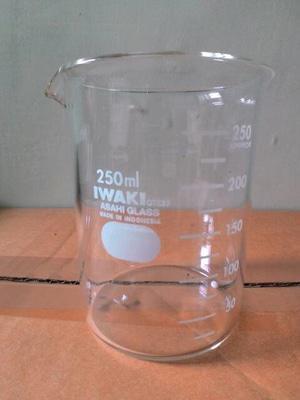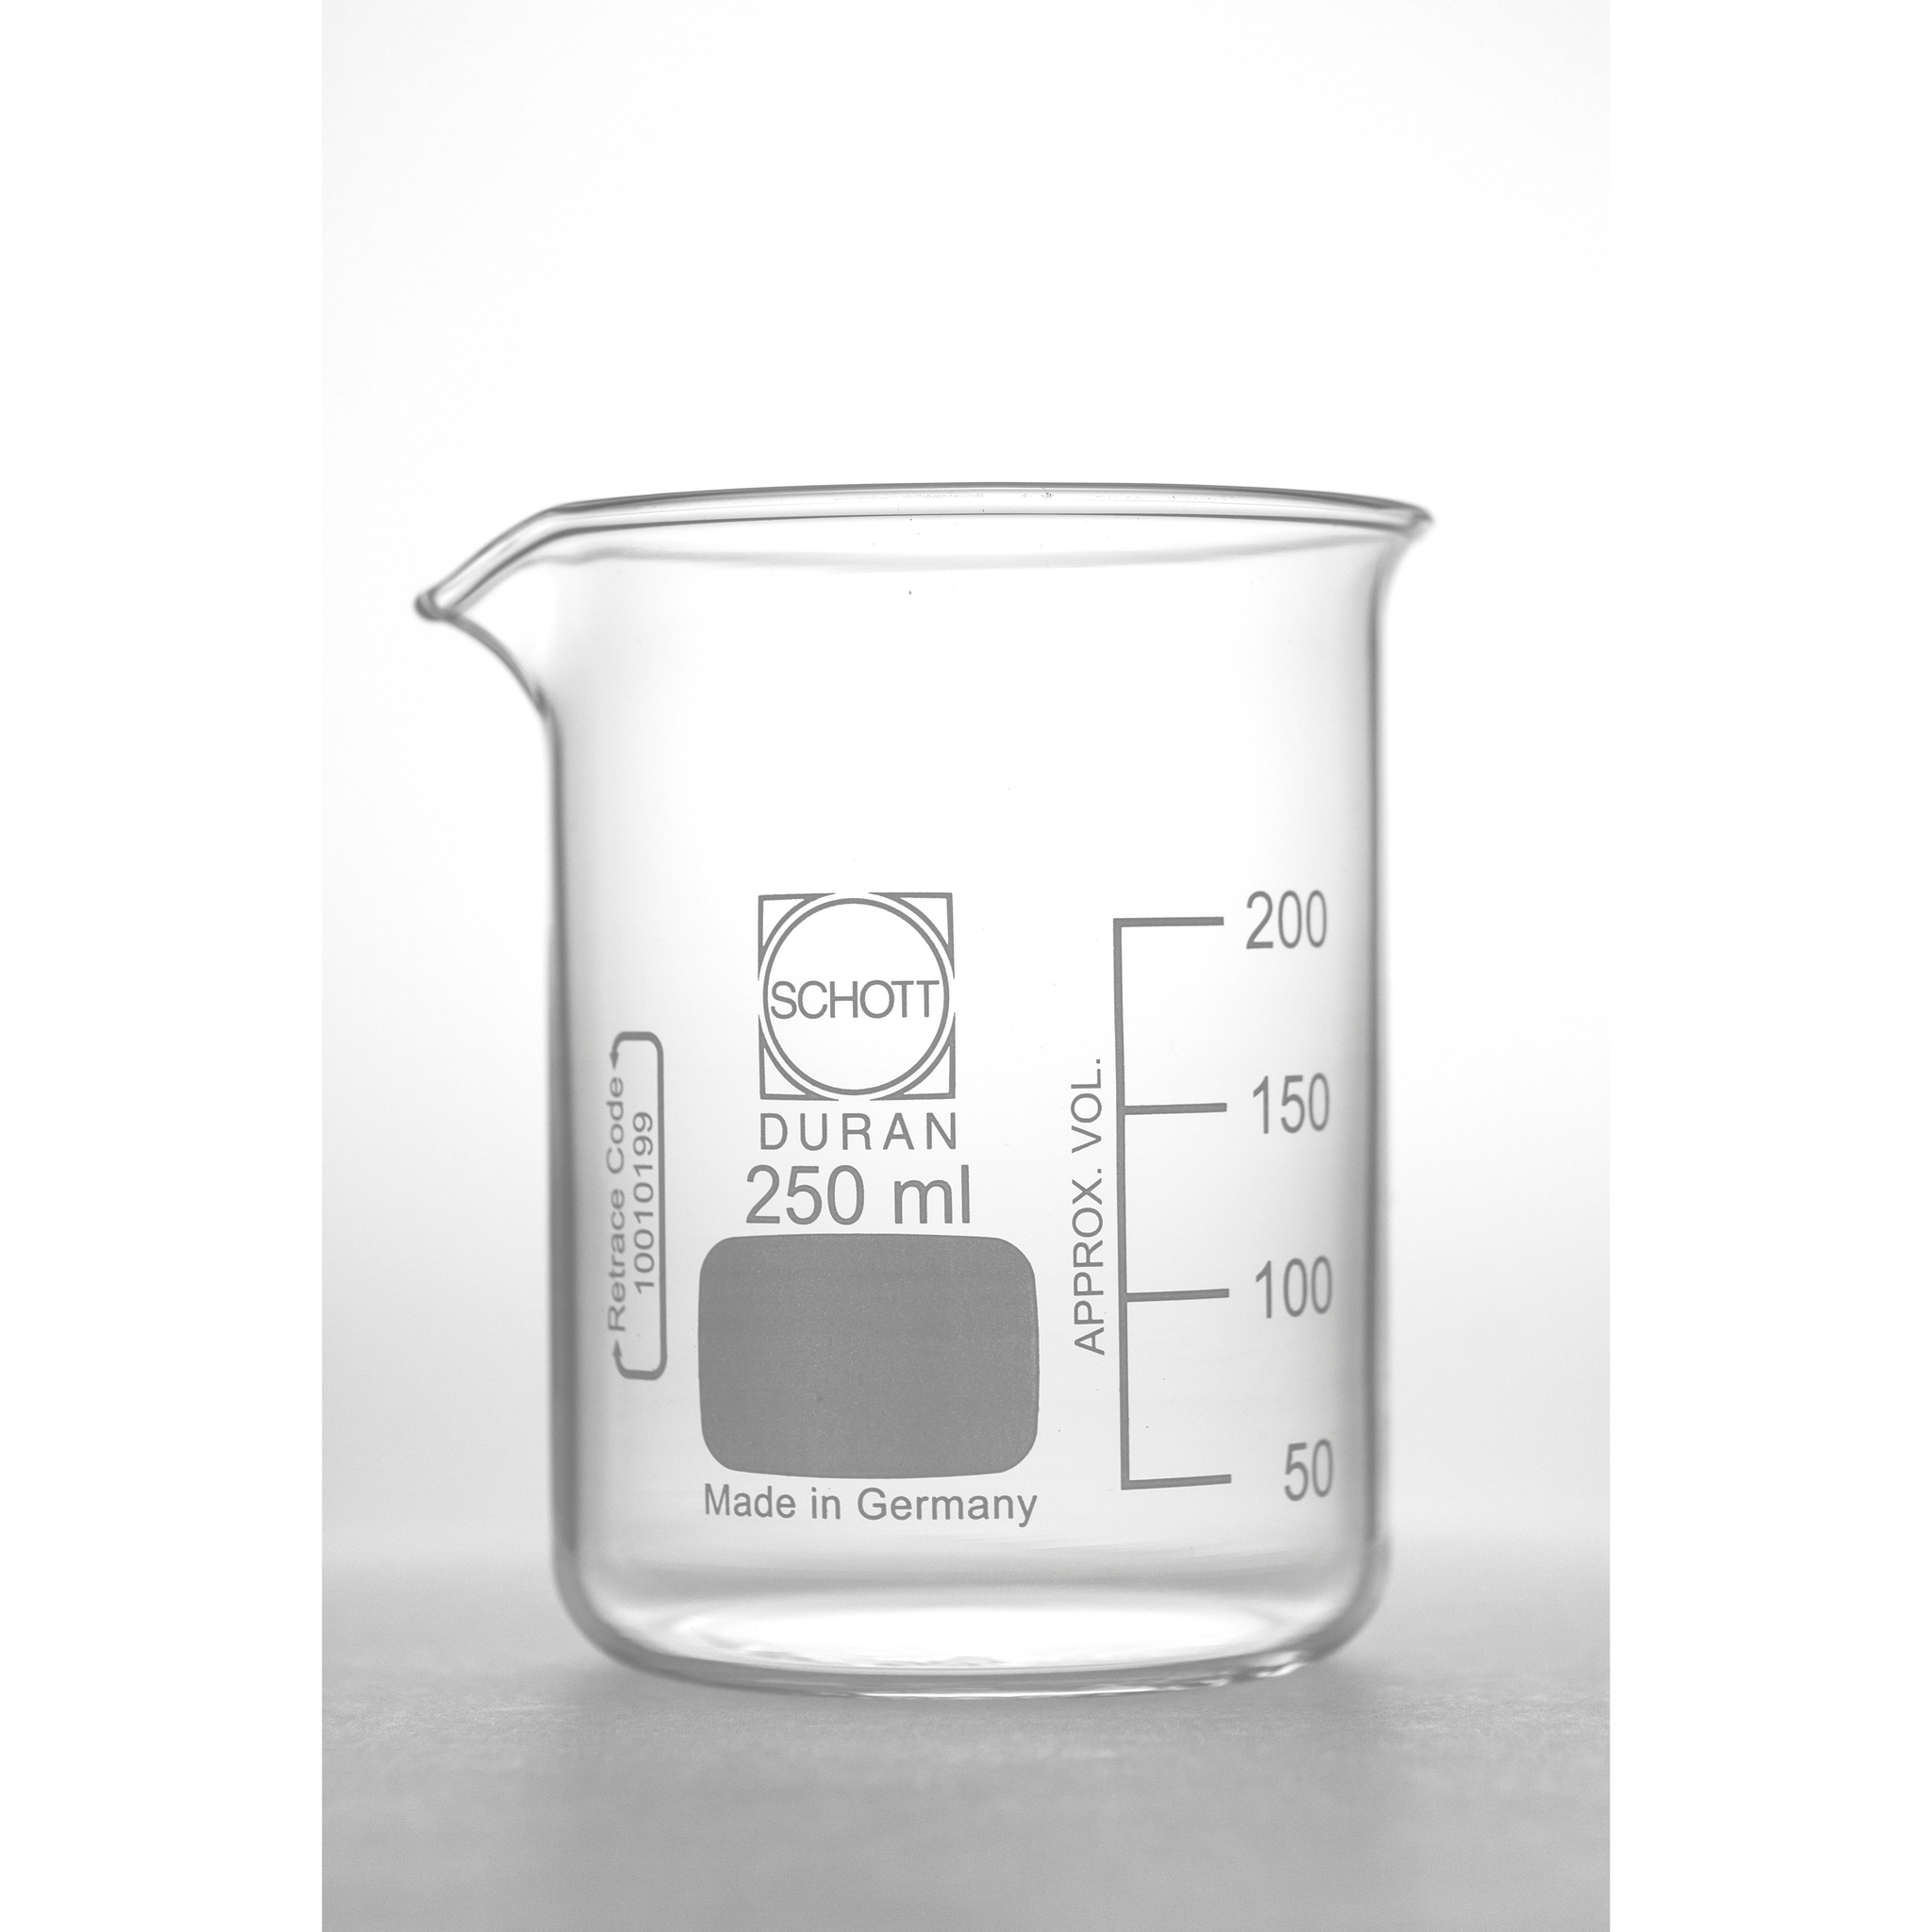The first image is the image on the left, the second image is the image on the right. For the images shown, is this caption "There are two beakers on a dark surface." true? Answer yes or no. No. The first image is the image on the left, the second image is the image on the right. Analyze the images presented: Is the assertion "There are just two beakers, and they are both on a dark background." valid? Answer yes or no. No. 